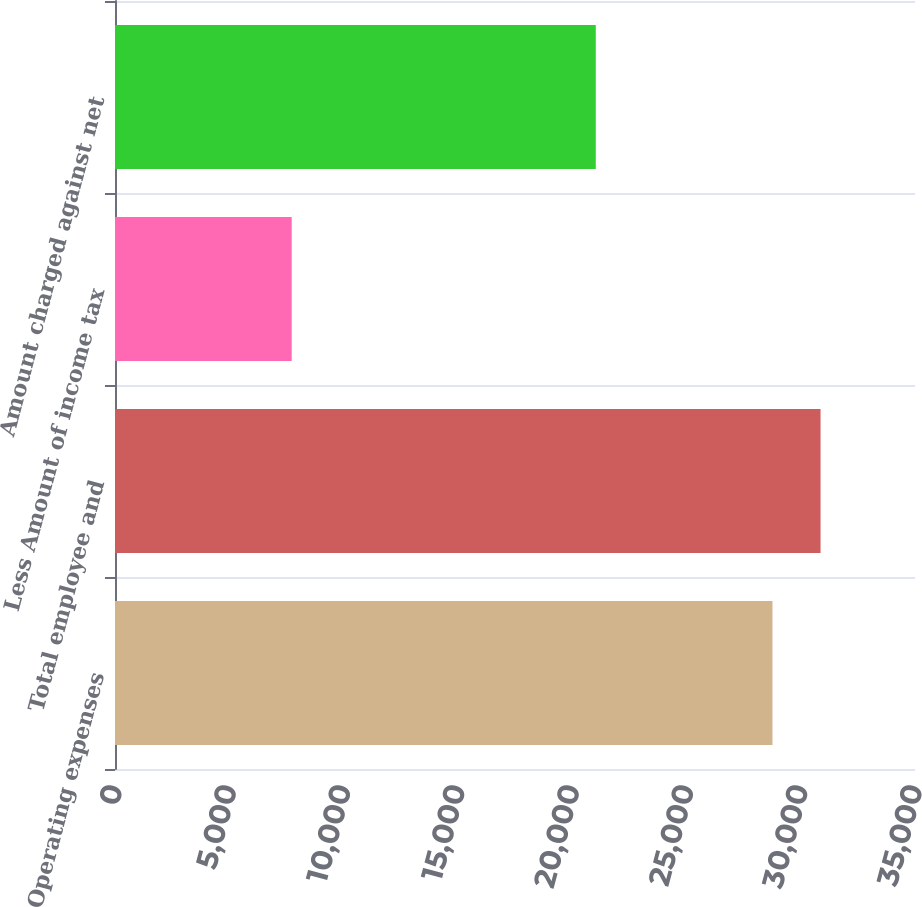<chart> <loc_0><loc_0><loc_500><loc_500><bar_chart><fcel>Operating expenses<fcel>Total employee and<fcel>Less Amount of income tax<fcel>Amount charged against net<nl><fcel>28764<fcel>30867.4<fcel>7730<fcel>21034<nl></chart> 